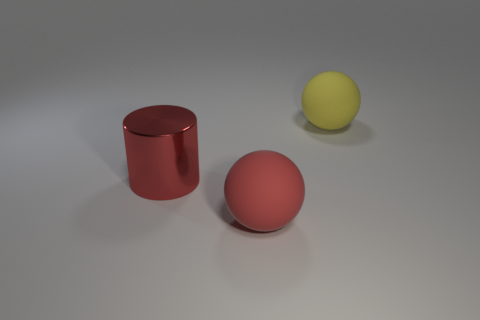Is there anything else that has the same size as the red rubber sphere?
Provide a short and direct response. Yes. There is a big thing to the left of the rubber sphere that is in front of the big red metallic object; what is its material?
Ensure brevity in your answer.  Metal. Does the yellow object have the same shape as the red rubber thing?
Give a very brief answer. Yes. What color is the matte object that is the same size as the yellow matte ball?
Your response must be concise. Red. Are there any big matte balls of the same color as the large shiny object?
Provide a short and direct response. Yes. Are any green metal blocks visible?
Your response must be concise. No. Is the material of the object behind the red metallic cylinder the same as the cylinder?
Your answer should be compact. No. What size is the thing that is the same color as the cylinder?
Ensure brevity in your answer.  Large. What number of yellow matte things are the same size as the red matte sphere?
Ensure brevity in your answer.  1. Are there an equal number of big metal cylinders that are in front of the red rubber thing and spheres?
Provide a short and direct response. No. 